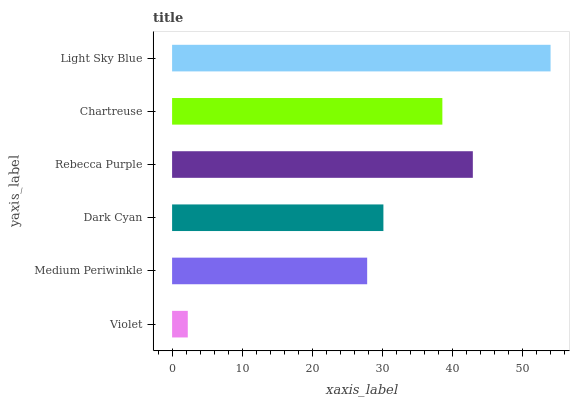Is Violet the minimum?
Answer yes or no. Yes. Is Light Sky Blue the maximum?
Answer yes or no. Yes. Is Medium Periwinkle the minimum?
Answer yes or no. No. Is Medium Periwinkle the maximum?
Answer yes or no. No. Is Medium Periwinkle greater than Violet?
Answer yes or no. Yes. Is Violet less than Medium Periwinkle?
Answer yes or no. Yes. Is Violet greater than Medium Periwinkle?
Answer yes or no. No. Is Medium Periwinkle less than Violet?
Answer yes or no. No. Is Chartreuse the high median?
Answer yes or no. Yes. Is Dark Cyan the low median?
Answer yes or no. Yes. Is Light Sky Blue the high median?
Answer yes or no. No. Is Rebecca Purple the low median?
Answer yes or no. No. 